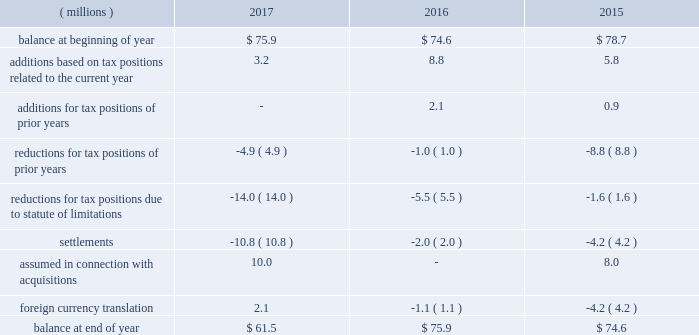The company 2019s 2017 reported tax rate includes $ 160.9 million of net tax benefits associated with the tax act , $ 6.2 million of net tax benefits on special gains and charges , and net tax benefits of $ 25.3 million associated with discrete tax items .
In connection with the company 2019s initial analysis of the impact of the tax act , as noted above , a provisional net discrete tax benefit of $ 160.9 million was recorded in the period ended december 31 , 2017 , which includes $ 321.0 million tax benefit for recording deferred tax assets and liabilities at the u.s .
Enacted tax rate , and a net expense for the one-time transition tax of $ 160.1 million .
While the company was able to make an estimate of the impact of the reduction in the u.s .
Rate on deferred tax assets and liabilities and the one-time transition tax , it may be affected by other analyses related to the tax act , as indicated above .
Special ( gains ) and charges represent the tax impact of special ( gains ) and charges , as well as additional tax benefits utilized in anticipation of u.s .
Tax reform of $ 7.8 million .
During 2017 , the company recorded a discrete tax benefit of $ 39.7 million related to excess tax benefits , resulting from the adoption of accounting changes regarding the treatment of tax benefits on share-based compensation .
The extent of excess tax benefits is subject to variation in stock price and stock option exercises .
In addition , the company recorded net discrete expenses of $ 14.4 million related to recognizing adjustments from filing the 2016 u.s .
Federal income tax return and international adjustments due to changes in estimates , partially offset by the release of reserves for uncertain tax positions due to the expiration of statute of limitations in state tax matters .
During 2016 , the company recognized net expense related to discrete tax items of $ 3.9 million .
The net expenses were driven primarily by recognizing adjustments from filing the company 2019s 2015 u.s .
Federal income tax return , partially offset by settlement of international tax matters and remeasurement of certain deferred tax assets and liabilities resulting from the application of updated tax rates in international jurisdictions .
Net expense was also impacted by adjustments to deferred tax asset and liability positions and the release of reserves for uncertain tax positions due to the expiration of statute of limitations in non-u.s .
Jurisdictions .
During 2015 , the company recognized net benefits related to discrete tax items of $ 63.3 million .
The net benefits were driven primarily by the release of $ 20.6 million of valuation allowances , based on the realizability of foreign deferred tax assets and the ability to recognize a worthless stock deduction of $ 39.0 million for the tax basis in a wholly-owned domestic subsidiary .
A reconciliation of the beginning and ending amount of gross liability for unrecognized tax benefits is as follows: .
The total amount of unrecognized tax benefits , if recognized would have affected the effective tax rate by $ 47.1 million as of december 31 , 2017 , $ 57.5 million as of december 31 , 2016 and $ 59.2 million as of december 31 , 2015 .
The company recognizes interest and penalties related to unrecognized tax benefits in its provision for income taxes .
During 2017 , 2016 and 2015 the company released $ 0.9 million , $ 2.9 million and $ 1.4 million related to interest and penalties , respectively .
The company had $ 9.3 million , $ 10.2 million and $ 13.1 million of accrued interest , including minor amounts for penalties , at december 31 , 2017 , 2016 , and 2015 , respectively. .
What is the percentage change in the balance of gross liability for unrecognized tax benefits from 2015 to 2016? 
Computations: ((75.9 - 74.6) / 74.6)
Answer: 0.01743. The company 2019s 2017 reported tax rate includes $ 160.9 million of net tax benefits associated with the tax act , $ 6.2 million of net tax benefits on special gains and charges , and net tax benefits of $ 25.3 million associated with discrete tax items .
In connection with the company 2019s initial analysis of the impact of the tax act , as noted above , a provisional net discrete tax benefit of $ 160.9 million was recorded in the period ended december 31 , 2017 , which includes $ 321.0 million tax benefit for recording deferred tax assets and liabilities at the u.s .
Enacted tax rate , and a net expense for the one-time transition tax of $ 160.1 million .
While the company was able to make an estimate of the impact of the reduction in the u.s .
Rate on deferred tax assets and liabilities and the one-time transition tax , it may be affected by other analyses related to the tax act , as indicated above .
Special ( gains ) and charges represent the tax impact of special ( gains ) and charges , as well as additional tax benefits utilized in anticipation of u.s .
Tax reform of $ 7.8 million .
During 2017 , the company recorded a discrete tax benefit of $ 39.7 million related to excess tax benefits , resulting from the adoption of accounting changes regarding the treatment of tax benefits on share-based compensation .
The extent of excess tax benefits is subject to variation in stock price and stock option exercises .
In addition , the company recorded net discrete expenses of $ 14.4 million related to recognizing adjustments from filing the 2016 u.s .
Federal income tax return and international adjustments due to changes in estimates , partially offset by the release of reserves for uncertain tax positions due to the expiration of statute of limitations in state tax matters .
During 2016 , the company recognized net expense related to discrete tax items of $ 3.9 million .
The net expenses were driven primarily by recognizing adjustments from filing the company 2019s 2015 u.s .
Federal income tax return , partially offset by settlement of international tax matters and remeasurement of certain deferred tax assets and liabilities resulting from the application of updated tax rates in international jurisdictions .
Net expense was also impacted by adjustments to deferred tax asset and liability positions and the release of reserves for uncertain tax positions due to the expiration of statute of limitations in non-u.s .
Jurisdictions .
During 2015 , the company recognized net benefits related to discrete tax items of $ 63.3 million .
The net benefits were driven primarily by the release of $ 20.6 million of valuation allowances , based on the realizability of foreign deferred tax assets and the ability to recognize a worthless stock deduction of $ 39.0 million for the tax basis in a wholly-owned domestic subsidiary .
A reconciliation of the beginning and ending amount of gross liability for unrecognized tax benefits is as follows: .
The total amount of unrecognized tax benefits , if recognized would have affected the effective tax rate by $ 47.1 million as of december 31 , 2017 , $ 57.5 million as of december 31 , 2016 and $ 59.2 million as of december 31 , 2015 .
The company recognizes interest and penalties related to unrecognized tax benefits in its provision for income taxes .
During 2017 , 2016 and 2015 the company released $ 0.9 million , $ 2.9 million and $ 1.4 million related to interest and penalties , respectively .
The company had $ 9.3 million , $ 10.2 million and $ 13.1 million of accrued interest , including minor amounts for penalties , at december 31 , 2017 , 2016 , and 2015 , respectively. .
What is the percentage change in the balance of gross liability for unrecognized tax benefits from 2016 to 2017? 
Computations: ((61.5 - 75.9) / 75.9)
Answer: -0.18972. The company 2019s 2017 reported tax rate includes $ 160.9 million of net tax benefits associated with the tax act , $ 6.2 million of net tax benefits on special gains and charges , and net tax benefits of $ 25.3 million associated with discrete tax items .
In connection with the company 2019s initial analysis of the impact of the tax act , as noted above , a provisional net discrete tax benefit of $ 160.9 million was recorded in the period ended december 31 , 2017 , which includes $ 321.0 million tax benefit for recording deferred tax assets and liabilities at the u.s .
Enacted tax rate , and a net expense for the one-time transition tax of $ 160.1 million .
While the company was able to make an estimate of the impact of the reduction in the u.s .
Rate on deferred tax assets and liabilities and the one-time transition tax , it may be affected by other analyses related to the tax act , as indicated above .
Special ( gains ) and charges represent the tax impact of special ( gains ) and charges , as well as additional tax benefits utilized in anticipation of u.s .
Tax reform of $ 7.8 million .
During 2017 , the company recorded a discrete tax benefit of $ 39.7 million related to excess tax benefits , resulting from the adoption of accounting changes regarding the treatment of tax benefits on share-based compensation .
The extent of excess tax benefits is subject to variation in stock price and stock option exercises .
In addition , the company recorded net discrete expenses of $ 14.4 million related to recognizing adjustments from filing the 2016 u.s .
Federal income tax return and international adjustments due to changes in estimates , partially offset by the release of reserves for uncertain tax positions due to the expiration of statute of limitations in state tax matters .
During 2016 , the company recognized net expense related to discrete tax items of $ 3.9 million .
The net expenses were driven primarily by recognizing adjustments from filing the company 2019s 2015 u.s .
Federal income tax return , partially offset by settlement of international tax matters and remeasurement of certain deferred tax assets and liabilities resulting from the application of updated tax rates in international jurisdictions .
Net expense was also impacted by adjustments to deferred tax asset and liability positions and the release of reserves for uncertain tax positions due to the expiration of statute of limitations in non-u.s .
Jurisdictions .
During 2015 , the company recognized net benefits related to discrete tax items of $ 63.3 million .
The net benefits were driven primarily by the release of $ 20.6 million of valuation allowances , based on the realizability of foreign deferred tax assets and the ability to recognize a worthless stock deduction of $ 39.0 million for the tax basis in a wholly-owned domestic subsidiary .
A reconciliation of the beginning and ending amount of gross liability for unrecognized tax benefits is as follows: .
The total amount of unrecognized tax benefits , if recognized would have affected the effective tax rate by $ 47.1 million as of december 31 , 2017 , $ 57.5 million as of december 31 , 2016 and $ 59.2 million as of december 31 , 2015 .
The company recognizes interest and penalties related to unrecognized tax benefits in its provision for income taxes .
During 2017 , 2016 and 2015 the company released $ 0.9 million , $ 2.9 million and $ 1.4 million related to interest and penalties , respectively .
The company had $ 9.3 million , $ 10.2 million and $ 13.1 million of accrued interest , including minor amounts for penalties , at december 31 , 2017 , 2016 , and 2015 , respectively. .
What was the change in millions in settlements between 2017 and 2016? 
Computations: (10.8 - 2)
Answer: 8.8. 